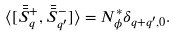<formula> <loc_0><loc_0><loc_500><loc_500>\langle [ \bar { \bar { S } } ^ { + } _ { q } , \bar { \bar { S } } ^ { - } _ { q ^ { \prime } } ] \rangle = N ^ { * } _ { \phi } \delta _ { q + q ^ { \prime } , 0 } .</formula> 